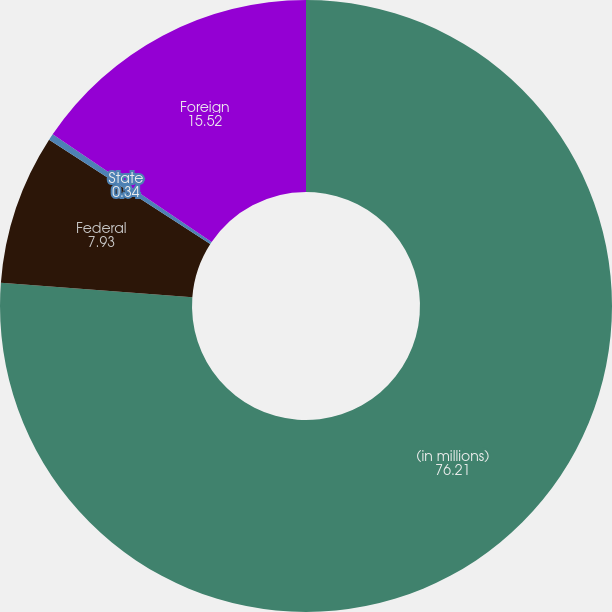Convert chart to OTSL. <chart><loc_0><loc_0><loc_500><loc_500><pie_chart><fcel>(in millions)<fcel>Federal<fcel>State<fcel>Foreign<nl><fcel>76.21%<fcel>7.93%<fcel>0.34%<fcel>15.52%<nl></chart> 